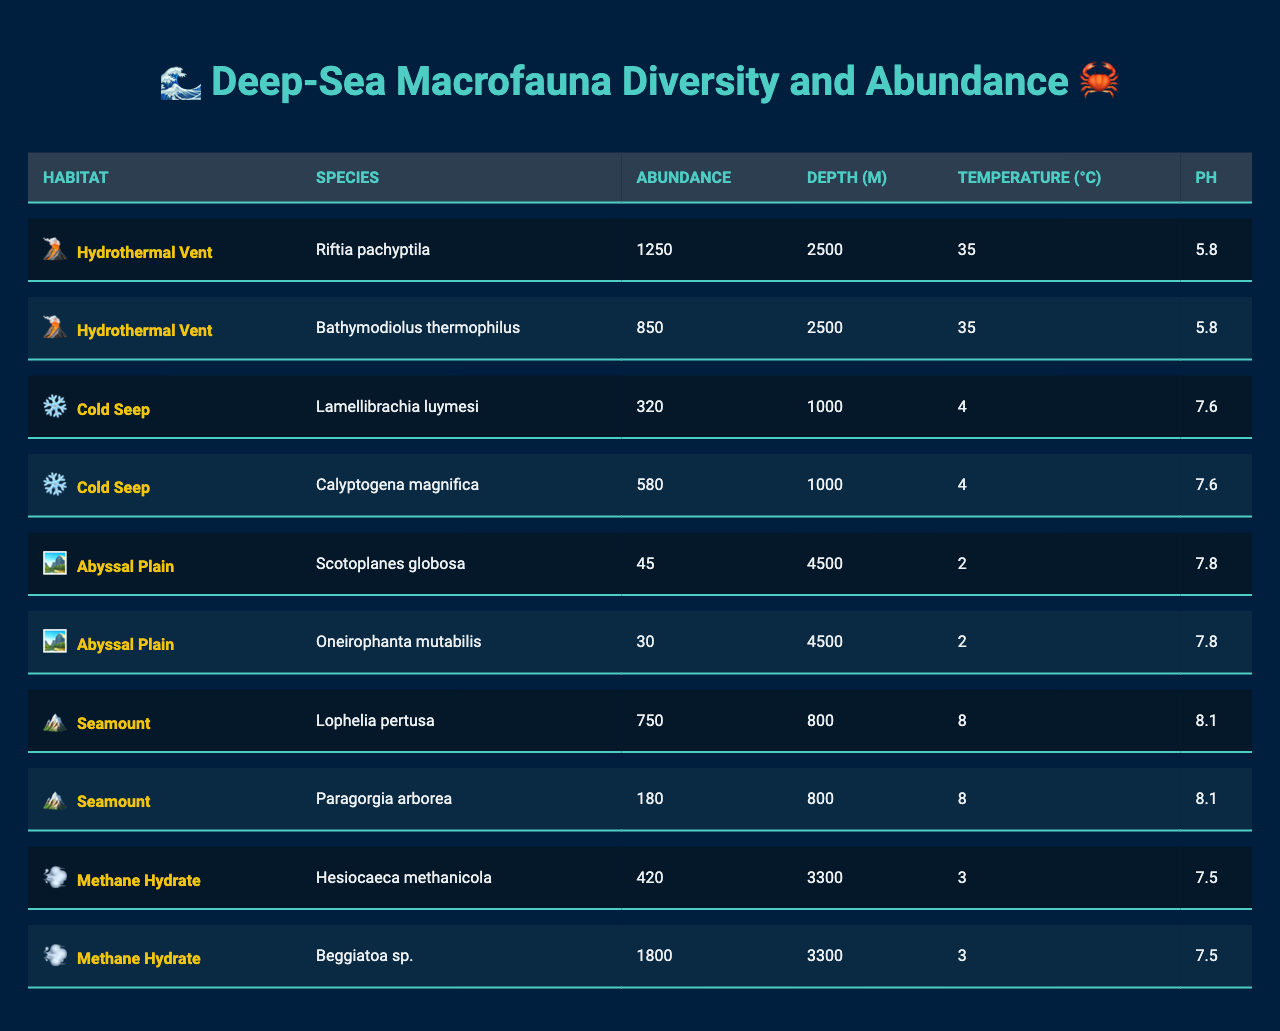What's the highest abundance of a species in the table? The highest abundance listed in the table is for the species "Beggiatoa sp." in the Methane Hydrate habitat, with an abundance of 1800 individuals.
Answer: 1800 Which habitat has the lowest species abundance? The Abyssal Plain has the lowest species abundance for the species "Scotoplanes globosa" with an abundance of 45.
Answer: 45 How many species are listed for Cold Seep habitats? There are two species listed for Cold Seep habitats: "Lamellibrachia luymesi" and "Calyptogena magnifica".
Answer: 2 What is the average abundance of species found in Hydrothermal Vent habitats? The average abundance for Hydrothermal Vent habitats can be calculated by summing the abundances (1250 + 850 = 2100) and then dividing by the number of species (2). So, 2100/2 = 1050.
Answer: 1050 Which species is found at the deepest depth? "Oneirophanta mutabilis" is found at the deepest depth of 4500 meters in the Abyssal Plain habitat.
Answer: Oneirophanta mutabilis Is there a species that occurs in the Seamount habitat with an abundance greater than 700? Yes, "Lophelia pertusa" occurs in the Seamount habitat with an abundance of 750.
Answer: Yes What is the total abundance of all species across the different habitats? The total abundance can be calculated by summing the individual abundances: 1250 + 850 + 320 + 580 + 45 + 30 + 750 + 180 + 420 + 1800 = 4025.
Answer: 4025 How does the pH of species in Hydrothermal Vent compare to those in Cold Seep? The pH of Hydrothermal Vent is 5.8, while that of Cold Seep is 7.6. This indicates that the Hydrothermal Vent is significantly more acidic than the Cold Seep.
Answer: More acidic Which habitat has more species: Seamount or Abyssal Plain? Seamount habitat has two species: "Lophelia pertusa" and "Paragorgia arborea", whereas the Abyssal Plain also features two: "Scotoplanes globosa" and "Oneirophanta mutabilis". Therefore, both habitats have an equal number of species.
Answer: Equal What is the pH range of all species listed in the table? The pH values in the table range from 5.8 (Hydrothermal Vent) to 8.1 (Seamount), so the range is from 5.8 to 8.1.
Answer: 5.8 to 8.1 